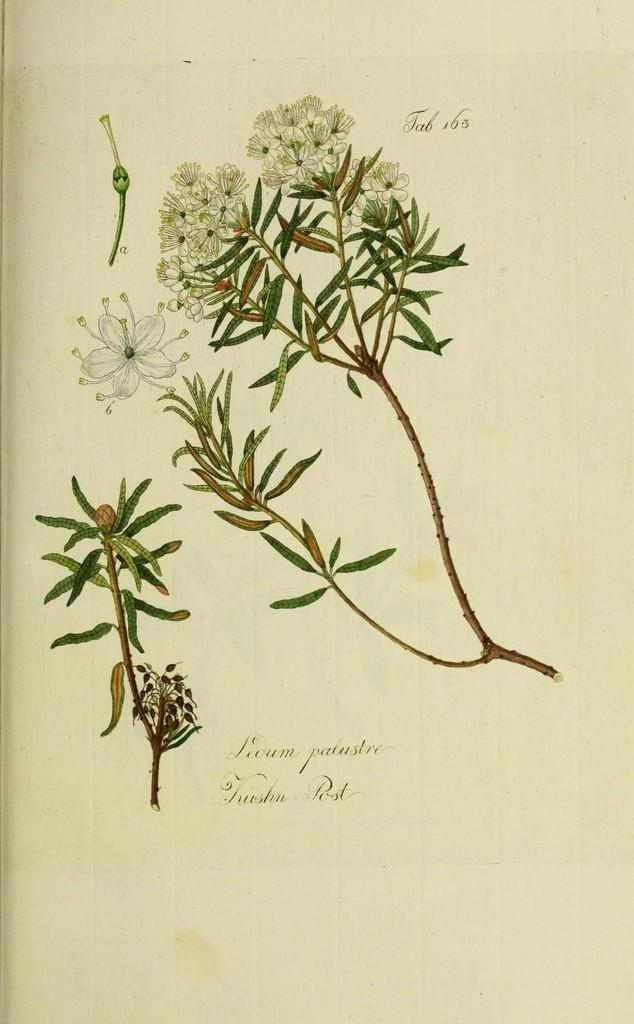What is depicted in the image? There is a picture of a plant in the image. What color are the leaves of the plant? The plant has green leaves. What type of flower does the plant have? The plant has a white flower. How does the jar affect the growth of the plant in the image? There is no jar present in the image, so it cannot affect the growth of the plant. 